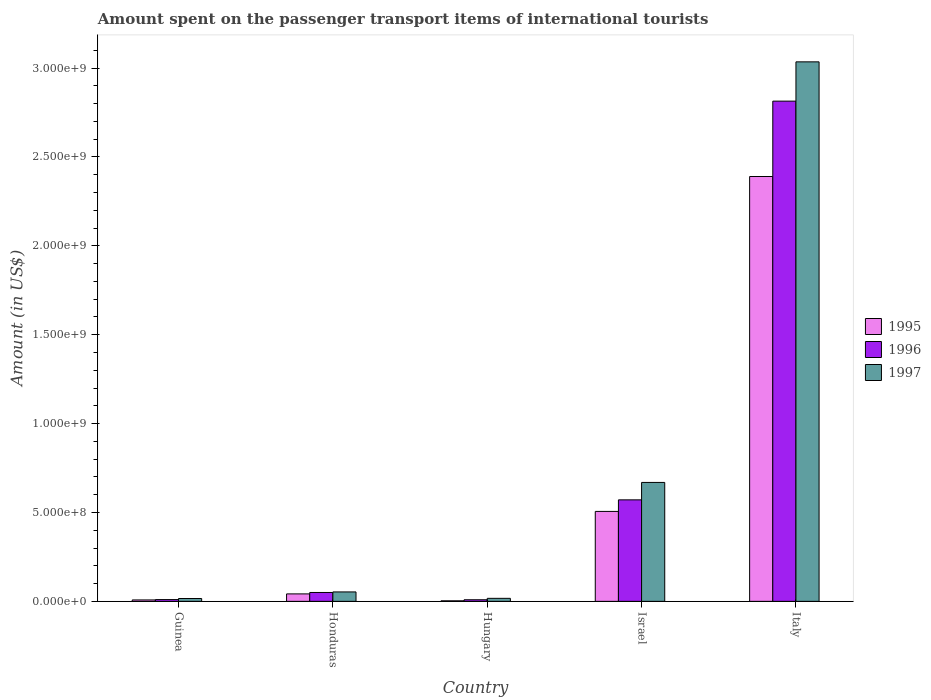How many different coloured bars are there?
Your response must be concise. 3. Are the number of bars per tick equal to the number of legend labels?
Give a very brief answer. Yes. How many bars are there on the 1st tick from the left?
Offer a very short reply. 3. What is the label of the 3rd group of bars from the left?
Your response must be concise. Hungary. In how many cases, is the number of bars for a given country not equal to the number of legend labels?
Provide a short and direct response. 0. What is the amount spent on the passenger transport items of international tourists in 1996 in Guinea?
Ensure brevity in your answer.  1.00e+07. Across all countries, what is the maximum amount spent on the passenger transport items of international tourists in 1997?
Keep it short and to the point. 3.04e+09. Across all countries, what is the minimum amount spent on the passenger transport items of international tourists in 1995?
Provide a short and direct response. 3.00e+06. In which country was the amount spent on the passenger transport items of international tourists in 1997 minimum?
Offer a terse response. Guinea. What is the total amount spent on the passenger transport items of international tourists in 1995 in the graph?
Ensure brevity in your answer.  2.95e+09. What is the difference between the amount spent on the passenger transport items of international tourists in 1997 in Israel and that in Italy?
Provide a short and direct response. -2.37e+09. What is the difference between the amount spent on the passenger transport items of international tourists in 1997 in Israel and the amount spent on the passenger transport items of international tourists in 1996 in Honduras?
Make the answer very short. 6.19e+08. What is the average amount spent on the passenger transport items of international tourists in 1997 per country?
Ensure brevity in your answer.  7.58e+08. What is the difference between the amount spent on the passenger transport items of international tourists of/in 1997 and amount spent on the passenger transport items of international tourists of/in 1995 in Hungary?
Your answer should be compact. 1.40e+07. What is the ratio of the amount spent on the passenger transport items of international tourists in 1995 in Hungary to that in Italy?
Ensure brevity in your answer.  0. Is the amount spent on the passenger transport items of international tourists in 1995 in Israel less than that in Italy?
Your answer should be compact. Yes. What is the difference between the highest and the second highest amount spent on the passenger transport items of international tourists in 1996?
Offer a very short reply. 2.76e+09. What is the difference between the highest and the lowest amount spent on the passenger transport items of international tourists in 1995?
Give a very brief answer. 2.39e+09. What does the 2nd bar from the right in Guinea represents?
Keep it short and to the point. 1996. Is it the case that in every country, the sum of the amount spent on the passenger transport items of international tourists in 1995 and amount spent on the passenger transport items of international tourists in 1997 is greater than the amount spent on the passenger transport items of international tourists in 1996?
Ensure brevity in your answer.  Yes. How many bars are there?
Your answer should be compact. 15. Does the graph contain grids?
Offer a very short reply. No. Where does the legend appear in the graph?
Give a very brief answer. Center right. What is the title of the graph?
Your answer should be very brief. Amount spent on the passenger transport items of international tourists. Does "1963" appear as one of the legend labels in the graph?
Offer a terse response. No. What is the label or title of the Y-axis?
Your answer should be very brief. Amount (in US$). What is the Amount (in US$) of 1996 in Guinea?
Your answer should be very brief. 1.00e+07. What is the Amount (in US$) in 1997 in Guinea?
Give a very brief answer. 1.60e+07. What is the Amount (in US$) of 1995 in Honduras?
Your answer should be very brief. 4.20e+07. What is the Amount (in US$) in 1997 in Honduras?
Ensure brevity in your answer.  5.30e+07. What is the Amount (in US$) in 1996 in Hungary?
Ensure brevity in your answer.  9.00e+06. What is the Amount (in US$) in 1997 in Hungary?
Offer a terse response. 1.70e+07. What is the Amount (in US$) in 1995 in Israel?
Provide a succinct answer. 5.06e+08. What is the Amount (in US$) in 1996 in Israel?
Provide a succinct answer. 5.71e+08. What is the Amount (in US$) of 1997 in Israel?
Ensure brevity in your answer.  6.69e+08. What is the Amount (in US$) of 1995 in Italy?
Your answer should be very brief. 2.39e+09. What is the Amount (in US$) in 1996 in Italy?
Offer a terse response. 2.81e+09. What is the Amount (in US$) of 1997 in Italy?
Offer a very short reply. 3.04e+09. Across all countries, what is the maximum Amount (in US$) of 1995?
Keep it short and to the point. 2.39e+09. Across all countries, what is the maximum Amount (in US$) in 1996?
Your response must be concise. 2.81e+09. Across all countries, what is the maximum Amount (in US$) in 1997?
Your answer should be compact. 3.04e+09. Across all countries, what is the minimum Amount (in US$) of 1995?
Offer a very short reply. 3.00e+06. Across all countries, what is the minimum Amount (in US$) in 1996?
Keep it short and to the point. 9.00e+06. Across all countries, what is the minimum Amount (in US$) in 1997?
Your answer should be compact. 1.60e+07. What is the total Amount (in US$) of 1995 in the graph?
Your response must be concise. 2.95e+09. What is the total Amount (in US$) of 1996 in the graph?
Provide a short and direct response. 3.45e+09. What is the total Amount (in US$) of 1997 in the graph?
Provide a short and direct response. 3.79e+09. What is the difference between the Amount (in US$) in 1995 in Guinea and that in Honduras?
Offer a very short reply. -3.40e+07. What is the difference between the Amount (in US$) of 1996 in Guinea and that in Honduras?
Keep it short and to the point. -4.00e+07. What is the difference between the Amount (in US$) in 1997 in Guinea and that in Honduras?
Ensure brevity in your answer.  -3.70e+07. What is the difference between the Amount (in US$) of 1995 in Guinea and that in Hungary?
Provide a succinct answer. 5.00e+06. What is the difference between the Amount (in US$) in 1995 in Guinea and that in Israel?
Offer a very short reply. -4.98e+08. What is the difference between the Amount (in US$) in 1996 in Guinea and that in Israel?
Keep it short and to the point. -5.61e+08. What is the difference between the Amount (in US$) in 1997 in Guinea and that in Israel?
Keep it short and to the point. -6.53e+08. What is the difference between the Amount (in US$) of 1995 in Guinea and that in Italy?
Ensure brevity in your answer.  -2.38e+09. What is the difference between the Amount (in US$) of 1996 in Guinea and that in Italy?
Your response must be concise. -2.80e+09. What is the difference between the Amount (in US$) of 1997 in Guinea and that in Italy?
Provide a succinct answer. -3.02e+09. What is the difference between the Amount (in US$) in 1995 in Honduras and that in Hungary?
Ensure brevity in your answer.  3.90e+07. What is the difference between the Amount (in US$) of 1996 in Honduras and that in Hungary?
Your answer should be compact. 4.10e+07. What is the difference between the Amount (in US$) in 1997 in Honduras and that in Hungary?
Provide a short and direct response. 3.60e+07. What is the difference between the Amount (in US$) in 1995 in Honduras and that in Israel?
Your answer should be compact. -4.64e+08. What is the difference between the Amount (in US$) in 1996 in Honduras and that in Israel?
Your answer should be compact. -5.21e+08. What is the difference between the Amount (in US$) in 1997 in Honduras and that in Israel?
Your answer should be compact. -6.16e+08. What is the difference between the Amount (in US$) of 1995 in Honduras and that in Italy?
Give a very brief answer. -2.35e+09. What is the difference between the Amount (in US$) of 1996 in Honduras and that in Italy?
Provide a succinct answer. -2.76e+09. What is the difference between the Amount (in US$) in 1997 in Honduras and that in Italy?
Keep it short and to the point. -2.98e+09. What is the difference between the Amount (in US$) of 1995 in Hungary and that in Israel?
Ensure brevity in your answer.  -5.03e+08. What is the difference between the Amount (in US$) of 1996 in Hungary and that in Israel?
Offer a very short reply. -5.62e+08. What is the difference between the Amount (in US$) in 1997 in Hungary and that in Israel?
Provide a succinct answer. -6.52e+08. What is the difference between the Amount (in US$) of 1995 in Hungary and that in Italy?
Provide a succinct answer. -2.39e+09. What is the difference between the Amount (in US$) in 1996 in Hungary and that in Italy?
Make the answer very short. -2.80e+09. What is the difference between the Amount (in US$) in 1997 in Hungary and that in Italy?
Your answer should be compact. -3.02e+09. What is the difference between the Amount (in US$) in 1995 in Israel and that in Italy?
Give a very brief answer. -1.88e+09. What is the difference between the Amount (in US$) of 1996 in Israel and that in Italy?
Your answer should be very brief. -2.24e+09. What is the difference between the Amount (in US$) in 1997 in Israel and that in Italy?
Provide a succinct answer. -2.37e+09. What is the difference between the Amount (in US$) in 1995 in Guinea and the Amount (in US$) in 1996 in Honduras?
Your answer should be compact. -4.20e+07. What is the difference between the Amount (in US$) in 1995 in Guinea and the Amount (in US$) in 1997 in Honduras?
Keep it short and to the point. -4.50e+07. What is the difference between the Amount (in US$) of 1996 in Guinea and the Amount (in US$) of 1997 in Honduras?
Keep it short and to the point. -4.30e+07. What is the difference between the Amount (in US$) of 1995 in Guinea and the Amount (in US$) of 1997 in Hungary?
Your answer should be very brief. -9.00e+06. What is the difference between the Amount (in US$) of 1996 in Guinea and the Amount (in US$) of 1997 in Hungary?
Make the answer very short. -7.00e+06. What is the difference between the Amount (in US$) of 1995 in Guinea and the Amount (in US$) of 1996 in Israel?
Your response must be concise. -5.63e+08. What is the difference between the Amount (in US$) of 1995 in Guinea and the Amount (in US$) of 1997 in Israel?
Keep it short and to the point. -6.61e+08. What is the difference between the Amount (in US$) in 1996 in Guinea and the Amount (in US$) in 1997 in Israel?
Give a very brief answer. -6.59e+08. What is the difference between the Amount (in US$) of 1995 in Guinea and the Amount (in US$) of 1996 in Italy?
Give a very brief answer. -2.81e+09. What is the difference between the Amount (in US$) of 1995 in Guinea and the Amount (in US$) of 1997 in Italy?
Offer a very short reply. -3.03e+09. What is the difference between the Amount (in US$) in 1996 in Guinea and the Amount (in US$) in 1997 in Italy?
Your answer should be very brief. -3.02e+09. What is the difference between the Amount (in US$) in 1995 in Honduras and the Amount (in US$) in 1996 in Hungary?
Provide a short and direct response. 3.30e+07. What is the difference between the Amount (in US$) of 1995 in Honduras and the Amount (in US$) of 1997 in Hungary?
Provide a short and direct response. 2.50e+07. What is the difference between the Amount (in US$) in 1996 in Honduras and the Amount (in US$) in 1997 in Hungary?
Offer a terse response. 3.30e+07. What is the difference between the Amount (in US$) of 1995 in Honduras and the Amount (in US$) of 1996 in Israel?
Provide a short and direct response. -5.29e+08. What is the difference between the Amount (in US$) of 1995 in Honduras and the Amount (in US$) of 1997 in Israel?
Provide a short and direct response. -6.27e+08. What is the difference between the Amount (in US$) of 1996 in Honduras and the Amount (in US$) of 1997 in Israel?
Offer a very short reply. -6.19e+08. What is the difference between the Amount (in US$) in 1995 in Honduras and the Amount (in US$) in 1996 in Italy?
Your answer should be very brief. -2.77e+09. What is the difference between the Amount (in US$) in 1995 in Honduras and the Amount (in US$) in 1997 in Italy?
Provide a succinct answer. -2.99e+09. What is the difference between the Amount (in US$) of 1996 in Honduras and the Amount (in US$) of 1997 in Italy?
Make the answer very short. -2.98e+09. What is the difference between the Amount (in US$) in 1995 in Hungary and the Amount (in US$) in 1996 in Israel?
Provide a short and direct response. -5.68e+08. What is the difference between the Amount (in US$) in 1995 in Hungary and the Amount (in US$) in 1997 in Israel?
Provide a succinct answer. -6.66e+08. What is the difference between the Amount (in US$) in 1996 in Hungary and the Amount (in US$) in 1997 in Israel?
Ensure brevity in your answer.  -6.60e+08. What is the difference between the Amount (in US$) of 1995 in Hungary and the Amount (in US$) of 1996 in Italy?
Give a very brief answer. -2.81e+09. What is the difference between the Amount (in US$) in 1995 in Hungary and the Amount (in US$) in 1997 in Italy?
Give a very brief answer. -3.03e+09. What is the difference between the Amount (in US$) in 1996 in Hungary and the Amount (in US$) in 1997 in Italy?
Provide a short and direct response. -3.03e+09. What is the difference between the Amount (in US$) in 1995 in Israel and the Amount (in US$) in 1996 in Italy?
Provide a succinct answer. -2.31e+09. What is the difference between the Amount (in US$) in 1995 in Israel and the Amount (in US$) in 1997 in Italy?
Your answer should be compact. -2.53e+09. What is the difference between the Amount (in US$) in 1996 in Israel and the Amount (in US$) in 1997 in Italy?
Give a very brief answer. -2.46e+09. What is the average Amount (in US$) in 1995 per country?
Provide a succinct answer. 5.90e+08. What is the average Amount (in US$) of 1996 per country?
Give a very brief answer. 6.91e+08. What is the average Amount (in US$) of 1997 per country?
Give a very brief answer. 7.58e+08. What is the difference between the Amount (in US$) in 1995 and Amount (in US$) in 1997 in Guinea?
Give a very brief answer. -8.00e+06. What is the difference between the Amount (in US$) in 1996 and Amount (in US$) in 1997 in Guinea?
Your answer should be very brief. -6.00e+06. What is the difference between the Amount (in US$) in 1995 and Amount (in US$) in 1996 in Honduras?
Offer a terse response. -8.00e+06. What is the difference between the Amount (in US$) in 1995 and Amount (in US$) in 1997 in Honduras?
Offer a terse response. -1.10e+07. What is the difference between the Amount (in US$) in 1995 and Amount (in US$) in 1996 in Hungary?
Ensure brevity in your answer.  -6.00e+06. What is the difference between the Amount (in US$) in 1995 and Amount (in US$) in 1997 in Hungary?
Ensure brevity in your answer.  -1.40e+07. What is the difference between the Amount (in US$) in 1996 and Amount (in US$) in 1997 in Hungary?
Your answer should be very brief. -8.00e+06. What is the difference between the Amount (in US$) of 1995 and Amount (in US$) of 1996 in Israel?
Offer a terse response. -6.50e+07. What is the difference between the Amount (in US$) in 1995 and Amount (in US$) in 1997 in Israel?
Give a very brief answer. -1.63e+08. What is the difference between the Amount (in US$) of 1996 and Amount (in US$) of 1997 in Israel?
Give a very brief answer. -9.80e+07. What is the difference between the Amount (in US$) in 1995 and Amount (in US$) in 1996 in Italy?
Keep it short and to the point. -4.24e+08. What is the difference between the Amount (in US$) in 1995 and Amount (in US$) in 1997 in Italy?
Give a very brief answer. -6.45e+08. What is the difference between the Amount (in US$) in 1996 and Amount (in US$) in 1997 in Italy?
Offer a very short reply. -2.21e+08. What is the ratio of the Amount (in US$) of 1995 in Guinea to that in Honduras?
Provide a short and direct response. 0.19. What is the ratio of the Amount (in US$) in 1997 in Guinea to that in Honduras?
Provide a short and direct response. 0.3. What is the ratio of the Amount (in US$) of 1995 in Guinea to that in Hungary?
Provide a short and direct response. 2.67. What is the ratio of the Amount (in US$) in 1996 in Guinea to that in Hungary?
Your answer should be very brief. 1.11. What is the ratio of the Amount (in US$) of 1997 in Guinea to that in Hungary?
Offer a terse response. 0.94. What is the ratio of the Amount (in US$) of 1995 in Guinea to that in Israel?
Make the answer very short. 0.02. What is the ratio of the Amount (in US$) in 1996 in Guinea to that in Israel?
Offer a very short reply. 0.02. What is the ratio of the Amount (in US$) of 1997 in Guinea to that in Israel?
Provide a short and direct response. 0.02. What is the ratio of the Amount (in US$) in 1995 in Guinea to that in Italy?
Your answer should be very brief. 0. What is the ratio of the Amount (in US$) in 1996 in Guinea to that in Italy?
Your answer should be very brief. 0. What is the ratio of the Amount (in US$) in 1997 in Guinea to that in Italy?
Your response must be concise. 0.01. What is the ratio of the Amount (in US$) of 1995 in Honduras to that in Hungary?
Offer a very short reply. 14. What is the ratio of the Amount (in US$) in 1996 in Honduras to that in Hungary?
Your answer should be very brief. 5.56. What is the ratio of the Amount (in US$) of 1997 in Honduras to that in Hungary?
Offer a terse response. 3.12. What is the ratio of the Amount (in US$) of 1995 in Honduras to that in Israel?
Provide a short and direct response. 0.08. What is the ratio of the Amount (in US$) of 1996 in Honduras to that in Israel?
Your response must be concise. 0.09. What is the ratio of the Amount (in US$) in 1997 in Honduras to that in Israel?
Give a very brief answer. 0.08. What is the ratio of the Amount (in US$) in 1995 in Honduras to that in Italy?
Provide a succinct answer. 0.02. What is the ratio of the Amount (in US$) in 1996 in Honduras to that in Italy?
Make the answer very short. 0.02. What is the ratio of the Amount (in US$) in 1997 in Honduras to that in Italy?
Give a very brief answer. 0.02. What is the ratio of the Amount (in US$) of 1995 in Hungary to that in Israel?
Ensure brevity in your answer.  0.01. What is the ratio of the Amount (in US$) in 1996 in Hungary to that in Israel?
Keep it short and to the point. 0.02. What is the ratio of the Amount (in US$) in 1997 in Hungary to that in Israel?
Your answer should be very brief. 0.03. What is the ratio of the Amount (in US$) of 1995 in Hungary to that in Italy?
Keep it short and to the point. 0. What is the ratio of the Amount (in US$) of 1996 in Hungary to that in Italy?
Give a very brief answer. 0. What is the ratio of the Amount (in US$) in 1997 in Hungary to that in Italy?
Provide a succinct answer. 0.01. What is the ratio of the Amount (in US$) in 1995 in Israel to that in Italy?
Provide a succinct answer. 0.21. What is the ratio of the Amount (in US$) in 1996 in Israel to that in Italy?
Provide a succinct answer. 0.2. What is the ratio of the Amount (in US$) in 1997 in Israel to that in Italy?
Your answer should be very brief. 0.22. What is the difference between the highest and the second highest Amount (in US$) in 1995?
Keep it short and to the point. 1.88e+09. What is the difference between the highest and the second highest Amount (in US$) in 1996?
Offer a terse response. 2.24e+09. What is the difference between the highest and the second highest Amount (in US$) in 1997?
Your response must be concise. 2.37e+09. What is the difference between the highest and the lowest Amount (in US$) of 1995?
Give a very brief answer. 2.39e+09. What is the difference between the highest and the lowest Amount (in US$) of 1996?
Your answer should be very brief. 2.80e+09. What is the difference between the highest and the lowest Amount (in US$) in 1997?
Make the answer very short. 3.02e+09. 